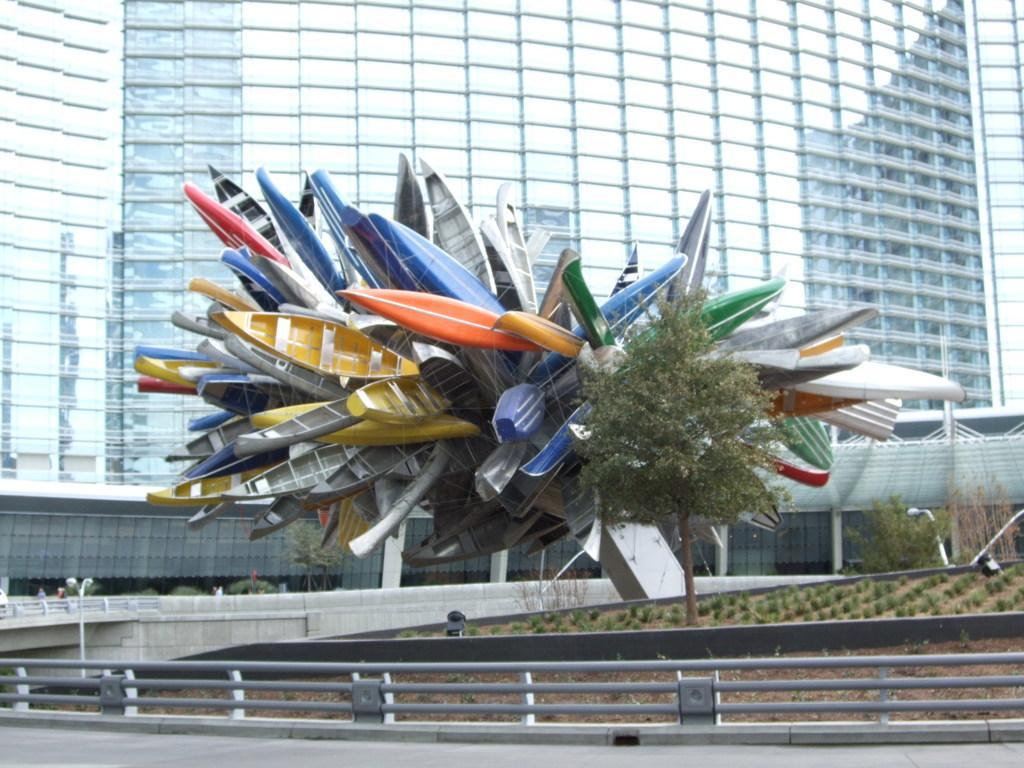In one or two sentences, can you explain what this image depicts? In this image, there is an outside view. There is a tree in the middle of the image. There is a bridge at the bottom of the image. In the background of the image, there is a building. 